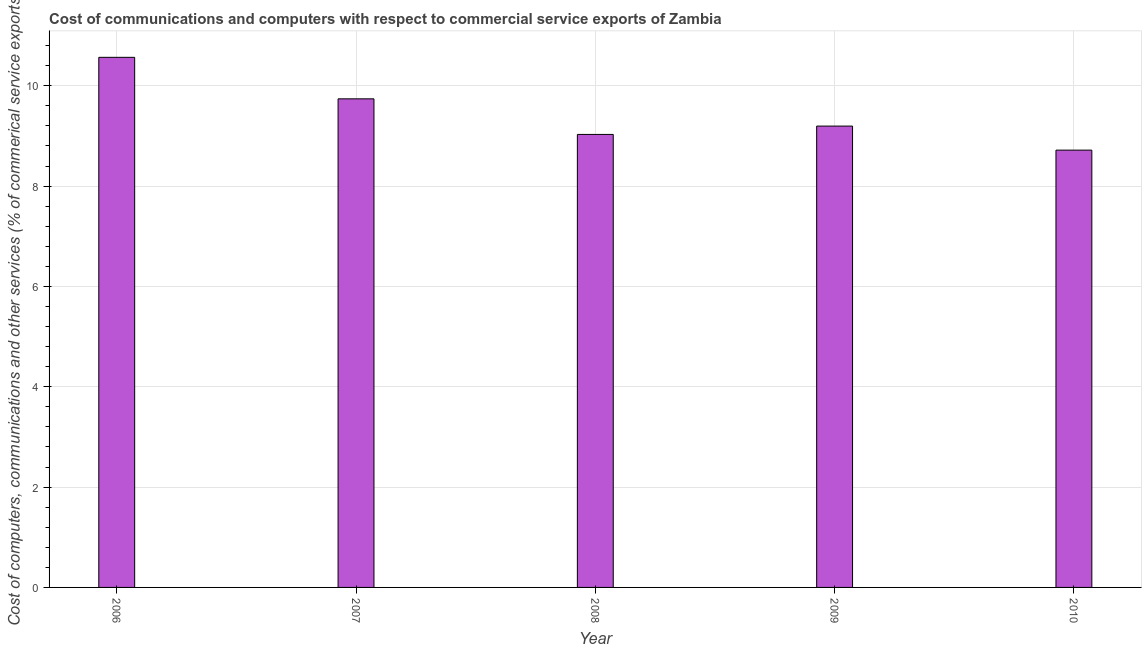What is the title of the graph?
Offer a terse response. Cost of communications and computers with respect to commercial service exports of Zambia. What is the label or title of the Y-axis?
Your response must be concise. Cost of computers, communications and other services (% of commerical service exports). What is the cost of communications in 2007?
Ensure brevity in your answer.  9.74. Across all years, what is the maximum cost of communications?
Your answer should be very brief. 10.57. Across all years, what is the minimum  computer and other services?
Your answer should be compact. 8.72. In which year was the cost of communications minimum?
Give a very brief answer. 2010. What is the sum of the  computer and other services?
Make the answer very short. 47.25. What is the difference between the  computer and other services in 2007 and 2009?
Keep it short and to the point. 0.54. What is the average cost of communications per year?
Provide a succinct answer. 9.45. What is the median cost of communications?
Provide a short and direct response. 9.2. What is the ratio of the cost of communications in 2006 to that in 2008?
Ensure brevity in your answer.  1.17. Is the cost of communications in 2006 less than that in 2008?
Offer a very short reply. No. What is the difference between the highest and the second highest cost of communications?
Give a very brief answer. 0.83. Is the sum of the cost of communications in 2006 and 2010 greater than the maximum cost of communications across all years?
Your answer should be very brief. Yes. What is the difference between the highest and the lowest  computer and other services?
Your response must be concise. 1.85. In how many years, is the  computer and other services greater than the average  computer and other services taken over all years?
Make the answer very short. 2. How many bars are there?
Give a very brief answer. 5. How many years are there in the graph?
Ensure brevity in your answer.  5. What is the difference between two consecutive major ticks on the Y-axis?
Offer a terse response. 2. Are the values on the major ticks of Y-axis written in scientific E-notation?
Offer a very short reply. No. What is the Cost of computers, communications and other services (% of commerical service exports) in 2006?
Offer a terse response. 10.57. What is the Cost of computers, communications and other services (% of commerical service exports) in 2007?
Your answer should be compact. 9.74. What is the Cost of computers, communications and other services (% of commerical service exports) of 2008?
Provide a succinct answer. 9.03. What is the Cost of computers, communications and other services (% of commerical service exports) of 2009?
Keep it short and to the point. 9.2. What is the Cost of computers, communications and other services (% of commerical service exports) in 2010?
Provide a succinct answer. 8.72. What is the difference between the Cost of computers, communications and other services (% of commerical service exports) in 2006 and 2007?
Give a very brief answer. 0.83. What is the difference between the Cost of computers, communications and other services (% of commerical service exports) in 2006 and 2008?
Offer a very short reply. 1.54. What is the difference between the Cost of computers, communications and other services (% of commerical service exports) in 2006 and 2009?
Your response must be concise. 1.37. What is the difference between the Cost of computers, communications and other services (% of commerical service exports) in 2006 and 2010?
Your answer should be compact. 1.85. What is the difference between the Cost of computers, communications and other services (% of commerical service exports) in 2007 and 2008?
Your response must be concise. 0.71. What is the difference between the Cost of computers, communications and other services (% of commerical service exports) in 2007 and 2009?
Your answer should be compact. 0.54. What is the difference between the Cost of computers, communications and other services (% of commerical service exports) in 2007 and 2010?
Your response must be concise. 1.02. What is the difference between the Cost of computers, communications and other services (% of commerical service exports) in 2008 and 2009?
Make the answer very short. -0.17. What is the difference between the Cost of computers, communications and other services (% of commerical service exports) in 2008 and 2010?
Provide a short and direct response. 0.31. What is the difference between the Cost of computers, communications and other services (% of commerical service exports) in 2009 and 2010?
Give a very brief answer. 0.48. What is the ratio of the Cost of computers, communications and other services (% of commerical service exports) in 2006 to that in 2007?
Ensure brevity in your answer.  1.08. What is the ratio of the Cost of computers, communications and other services (% of commerical service exports) in 2006 to that in 2008?
Give a very brief answer. 1.17. What is the ratio of the Cost of computers, communications and other services (% of commerical service exports) in 2006 to that in 2009?
Ensure brevity in your answer.  1.15. What is the ratio of the Cost of computers, communications and other services (% of commerical service exports) in 2006 to that in 2010?
Your response must be concise. 1.21. What is the ratio of the Cost of computers, communications and other services (% of commerical service exports) in 2007 to that in 2008?
Your answer should be very brief. 1.08. What is the ratio of the Cost of computers, communications and other services (% of commerical service exports) in 2007 to that in 2009?
Provide a short and direct response. 1.06. What is the ratio of the Cost of computers, communications and other services (% of commerical service exports) in 2007 to that in 2010?
Provide a short and direct response. 1.12. What is the ratio of the Cost of computers, communications and other services (% of commerical service exports) in 2008 to that in 2010?
Offer a very short reply. 1.04. What is the ratio of the Cost of computers, communications and other services (% of commerical service exports) in 2009 to that in 2010?
Keep it short and to the point. 1.05. 